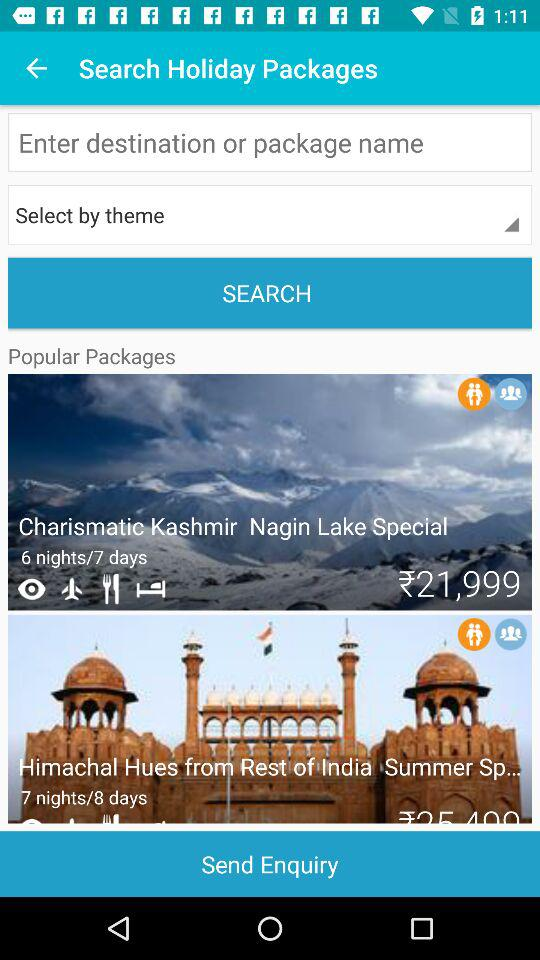Are there any cultural or heritage sites included in these packages? Both packages, 'Charismatic Kashmir' and 'Himachal Hues,' likely include visits to cultural and heritage sites. For Kashmir, heritage sites might include the old city of Srinagar and various shrines, while the Himachal package might feature ancient temples, monasteries, and colonial-era buildings, reflecting the rich historical tapestry of the region. 